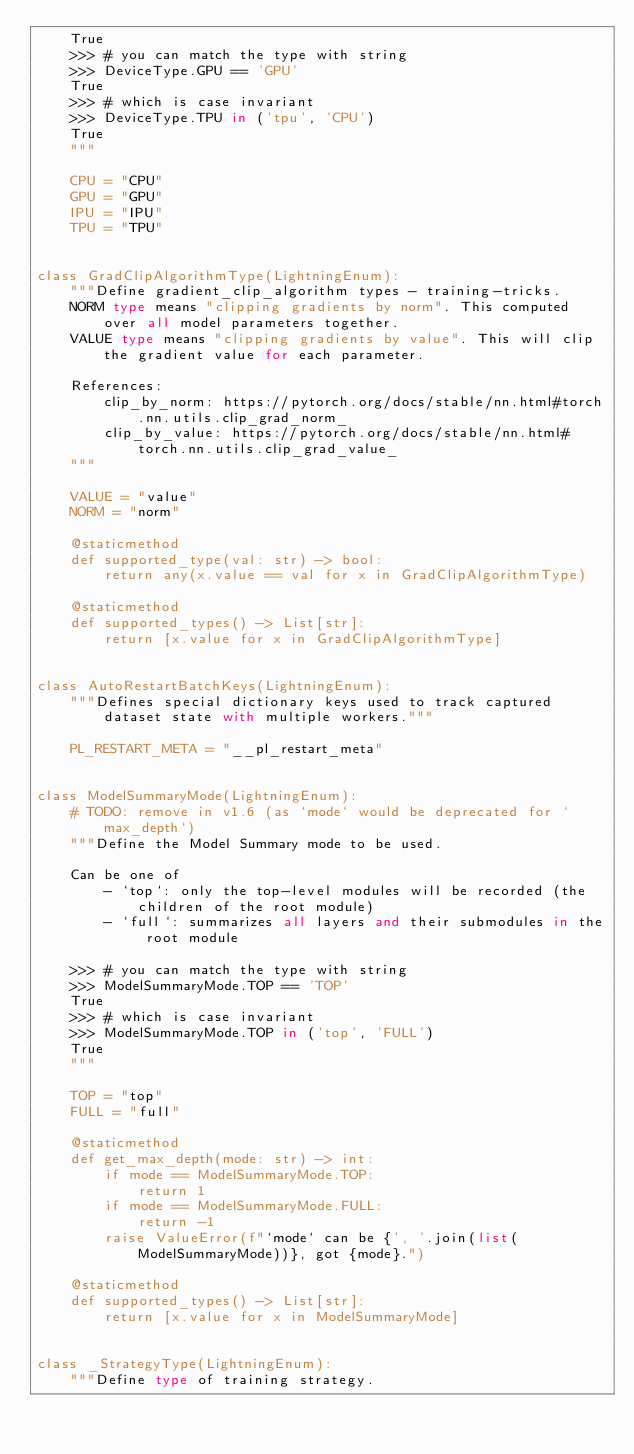Convert code to text. <code><loc_0><loc_0><loc_500><loc_500><_Python_>    True
    >>> # you can match the type with string
    >>> DeviceType.GPU == 'GPU'
    True
    >>> # which is case invariant
    >>> DeviceType.TPU in ('tpu', 'CPU')
    True
    """

    CPU = "CPU"
    GPU = "GPU"
    IPU = "IPU"
    TPU = "TPU"


class GradClipAlgorithmType(LightningEnum):
    """Define gradient_clip_algorithm types - training-tricks.
    NORM type means "clipping gradients by norm". This computed over all model parameters together.
    VALUE type means "clipping gradients by value". This will clip the gradient value for each parameter.

    References:
        clip_by_norm: https://pytorch.org/docs/stable/nn.html#torch.nn.utils.clip_grad_norm_
        clip_by_value: https://pytorch.org/docs/stable/nn.html#torch.nn.utils.clip_grad_value_
    """

    VALUE = "value"
    NORM = "norm"

    @staticmethod
    def supported_type(val: str) -> bool:
        return any(x.value == val for x in GradClipAlgorithmType)

    @staticmethod
    def supported_types() -> List[str]:
        return [x.value for x in GradClipAlgorithmType]


class AutoRestartBatchKeys(LightningEnum):
    """Defines special dictionary keys used to track captured dataset state with multiple workers."""

    PL_RESTART_META = "__pl_restart_meta"


class ModelSummaryMode(LightningEnum):
    # TODO: remove in v1.6 (as `mode` would be deprecated for `max_depth`)
    """Define the Model Summary mode to be used.

    Can be one of
        - `top`: only the top-level modules will be recorded (the children of the root module)
        - `full`: summarizes all layers and their submodules in the root module

    >>> # you can match the type with string
    >>> ModelSummaryMode.TOP == 'TOP'
    True
    >>> # which is case invariant
    >>> ModelSummaryMode.TOP in ('top', 'FULL')
    True
    """

    TOP = "top"
    FULL = "full"

    @staticmethod
    def get_max_depth(mode: str) -> int:
        if mode == ModelSummaryMode.TOP:
            return 1
        if mode == ModelSummaryMode.FULL:
            return -1
        raise ValueError(f"`mode` can be {', '.join(list(ModelSummaryMode))}, got {mode}.")

    @staticmethod
    def supported_types() -> List[str]:
        return [x.value for x in ModelSummaryMode]


class _StrategyType(LightningEnum):
    """Define type of training strategy.
</code> 